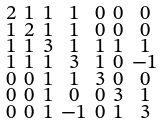<formula> <loc_0><loc_0><loc_500><loc_500>\begin{smallmatrix} 2 & 1 & 1 & 1 & 0 & 0 & 0 \\ 1 & 2 & 1 & 1 & 0 & 0 & 0 \\ 1 & 1 & 3 & 1 & 1 & 1 & 1 \\ 1 & 1 & 1 & 3 & 1 & 0 & - 1 \\ 0 & 0 & 1 & 1 & 3 & 0 & 0 \\ 0 & 0 & 1 & 0 & 0 & 3 & 1 \\ 0 & 0 & 1 & - 1 & 0 & 1 & 3 \end{smallmatrix}</formula> 